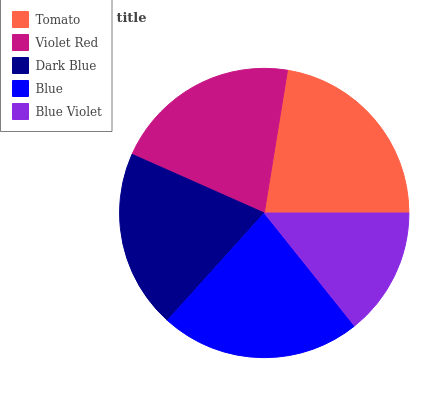Is Blue Violet the minimum?
Answer yes or no. Yes. Is Tomato the maximum?
Answer yes or no. Yes. Is Violet Red the minimum?
Answer yes or no. No. Is Violet Red the maximum?
Answer yes or no. No. Is Tomato greater than Violet Red?
Answer yes or no. Yes. Is Violet Red less than Tomato?
Answer yes or no. Yes. Is Violet Red greater than Tomato?
Answer yes or no. No. Is Tomato less than Violet Red?
Answer yes or no. No. Is Violet Red the high median?
Answer yes or no. Yes. Is Violet Red the low median?
Answer yes or no. Yes. Is Blue Violet the high median?
Answer yes or no. No. Is Blue the low median?
Answer yes or no. No. 